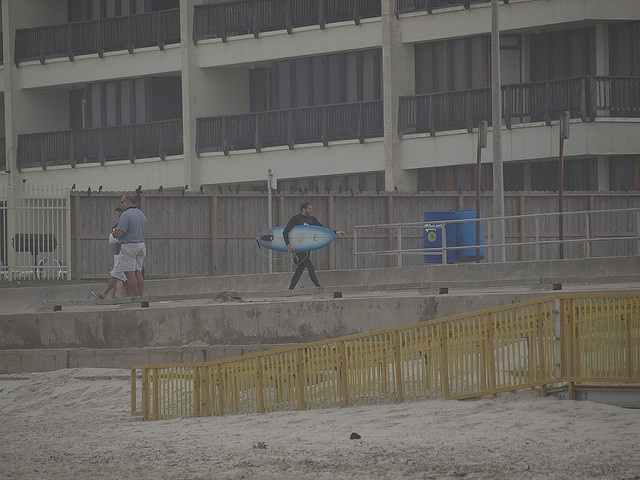Describe the objects in this image and their specific colors. I can see people in black and gray tones, people in black and gray tones, surfboard in black and gray tones, and people in black and gray tones in this image. 